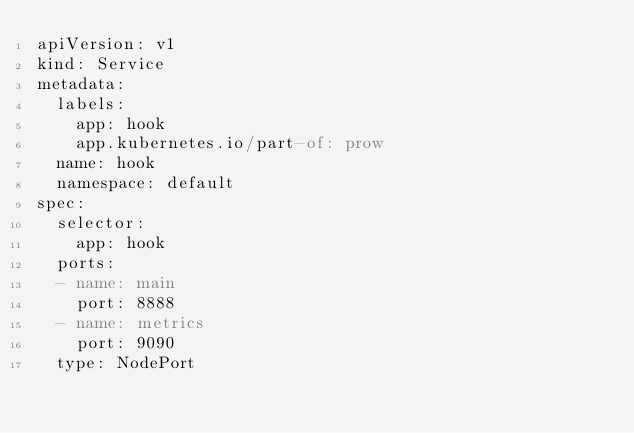<code> <loc_0><loc_0><loc_500><loc_500><_YAML_>apiVersion: v1
kind: Service
metadata:
  labels:
    app: hook
    app.kubernetes.io/part-of: prow
  name: hook
  namespace: default
spec:
  selector:
    app: hook
  ports:
  - name: main
    port: 8888
  - name: metrics
    port: 9090
  type: NodePort
</code> 